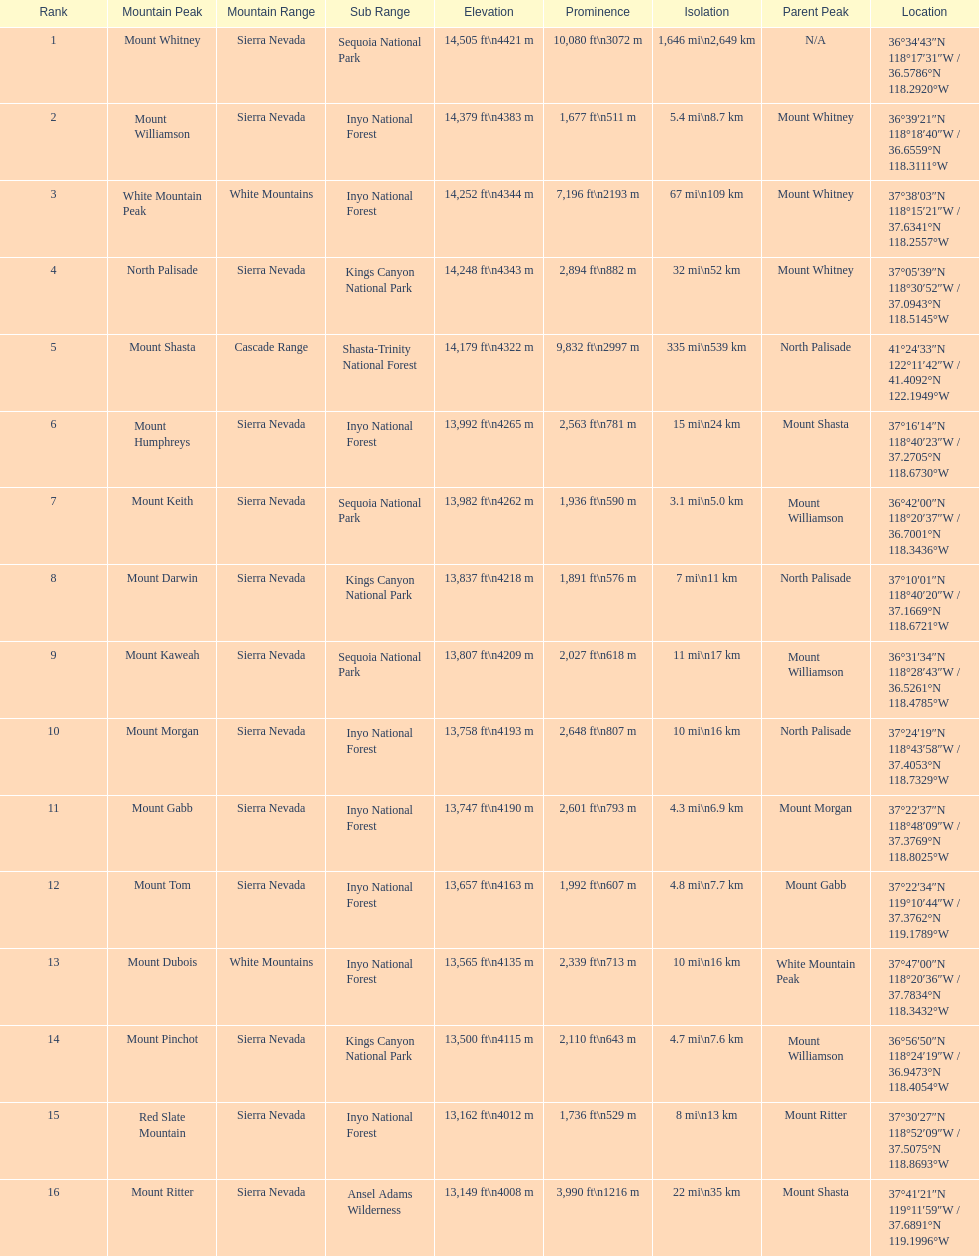What are all of the peaks? Mount Whitney, Mount Williamson, White Mountain Peak, North Palisade, Mount Shasta, Mount Humphreys, Mount Keith, Mount Darwin, Mount Kaweah, Mount Morgan, Mount Gabb, Mount Tom, Mount Dubois, Mount Pinchot, Red Slate Mountain, Mount Ritter. Where are they located? Sierra Nevada, Sierra Nevada, White Mountains, Sierra Nevada, Cascade Range, Sierra Nevada, Sierra Nevada, Sierra Nevada, Sierra Nevada, Sierra Nevada, Sierra Nevada, Sierra Nevada, White Mountains, Sierra Nevada, Sierra Nevada, Sierra Nevada. How tall are they? 14,505 ft\n4421 m, 14,379 ft\n4383 m, 14,252 ft\n4344 m, 14,248 ft\n4343 m, 14,179 ft\n4322 m, 13,992 ft\n4265 m, 13,982 ft\n4262 m, 13,837 ft\n4218 m, 13,807 ft\n4209 m, 13,758 ft\n4193 m, 13,747 ft\n4190 m, 13,657 ft\n4163 m, 13,565 ft\n4135 m, 13,500 ft\n4115 m, 13,162 ft\n4012 m, 13,149 ft\n4008 m. What about just the peaks in the sierra nevadas? 14,505 ft\n4421 m, 14,379 ft\n4383 m, 14,248 ft\n4343 m, 13,992 ft\n4265 m, 13,982 ft\n4262 m, 13,837 ft\n4218 m, 13,807 ft\n4209 m, 13,758 ft\n4193 m, 13,747 ft\n4190 m, 13,657 ft\n4163 m, 13,500 ft\n4115 m, 13,162 ft\n4012 m, 13,149 ft\n4008 m. And of those, which is the tallest? Mount Whitney. 